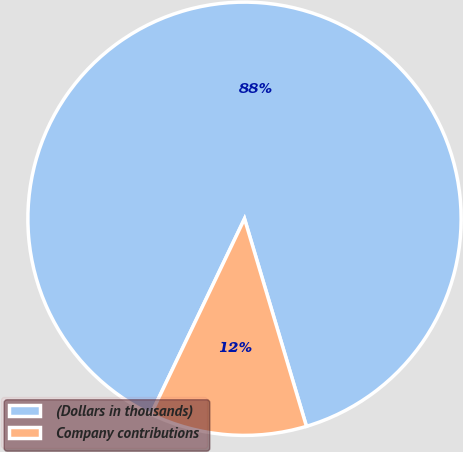Convert chart. <chart><loc_0><loc_0><loc_500><loc_500><pie_chart><fcel>(Dollars in thousands)<fcel>Company contributions<nl><fcel>88.28%<fcel>11.72%<nl></chart> 